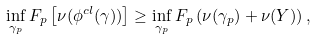Convert formula to latex. <formula><loc_0><loc_0><loc_500><loc_500>\inf _ { \gamma _ { p } } F _ { p } \left [ \nu ( \phi ^ { c l } ( \gamma ) ) \right ] \geq \inf _ { \gamma _ { p } } F _ { p } \left ( \nu ( \gamma _ { p } ) + \nu ( Y ) \right ) ,</formula> 